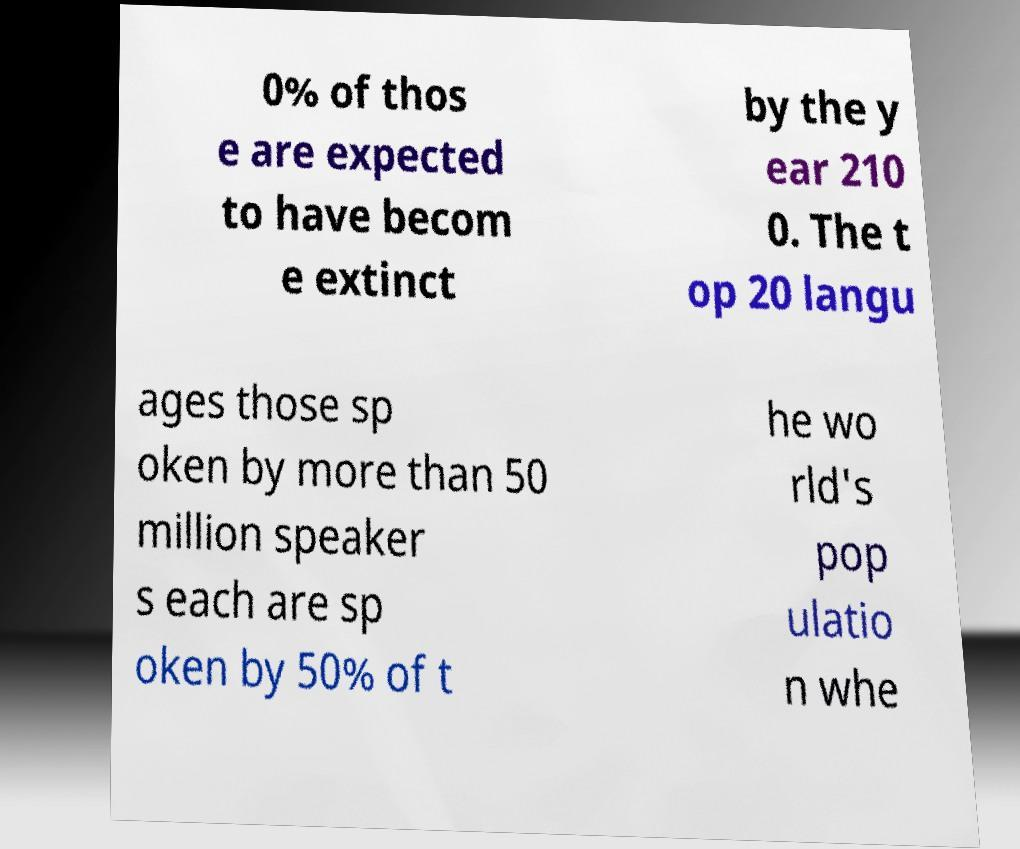What messages or text are displayed in this image? I need them in a readable, typed format. 0% of thos e are expected to have becom e extinct by the y ear 210 0. The t op 20 langu ages those sp oken by more than 50 million speaker s each are sp oken by 50% of t he wo rld's pop ulatio n whe 